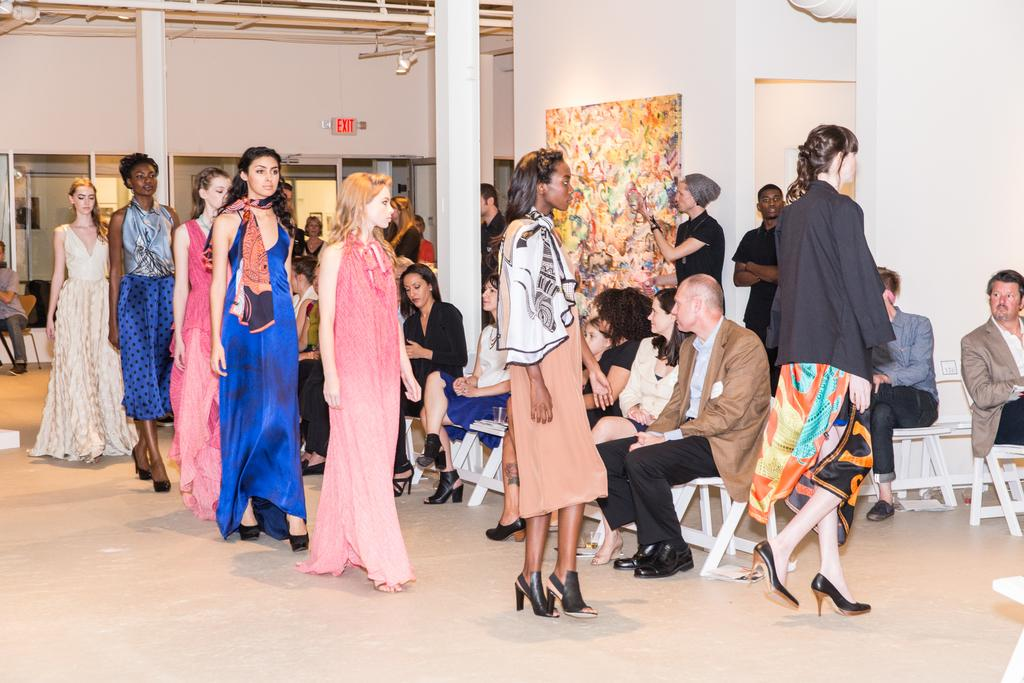Who are the subjects in the image? There are girls in the image. What are the girls doing in the image? The girls are doing a catwalk in the image. What type of footwear are the girls wearing? The girls are wearing heels in the image. Can you see the mom of the girls in the image? There is no mention of a mom in the image, so we cannot determine if she is present or not. Is there a battle taking place in the image? There is no indication of a battle in the image; the girls are doing a catwalk. 